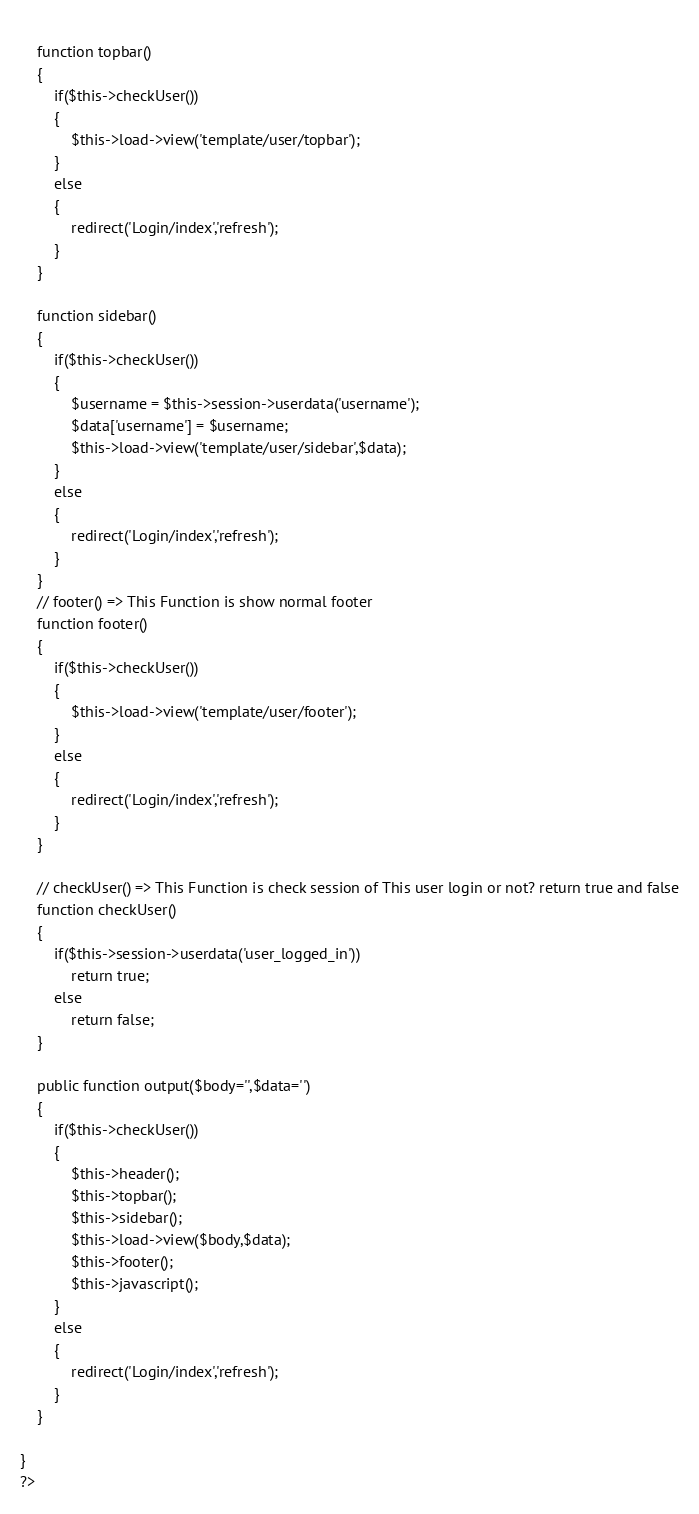<code> <loc_0><loc_0><loc_500><loc_500><_PHP_>	
	function topbar()
	{	
		if($this->checkUser())
		{
			$this->load->view('template/user/topbar');
		}
		else
		{
			redirect('Login/index','refresh');
		}		
	}
	
	function sidebar()
	{	
		if($this->checkUser())
		{
			$username = $this->session->userdata('username');
			$data['username'] = $username;
			$this->load->view('template/user/sidebar',$data);
		}
		else
		{
			redirect('Login/index','refresh');
		}		
	}
	// footer() => This Function is show normal footer 
	function footer()
	{
		if($this->checkUser())
		{
			$this->load->view('template/user/footer');
		}
		else
		{
			redirect('Login/index','refresh');
		}		
	}
	
	// checkUser() => This Function is check session of This user login or not? return true and false
	function checkUser()
	{
		if($this->session->userdata('user_logged_in'))
			return true;
		else
			return false;
	}
	
	public function output($body='',$data='')
	{		
		if($this->checkUser())
		{
			$this->header();			
			$this->topbar();
			$this->sidebar();			
			$this->load->view($body,$data);
			$this->footer();
			$this->javascript();
		}
		else
		{
			redirect('Login/index','refresh');
		}
	}	

}
?>
</code> 